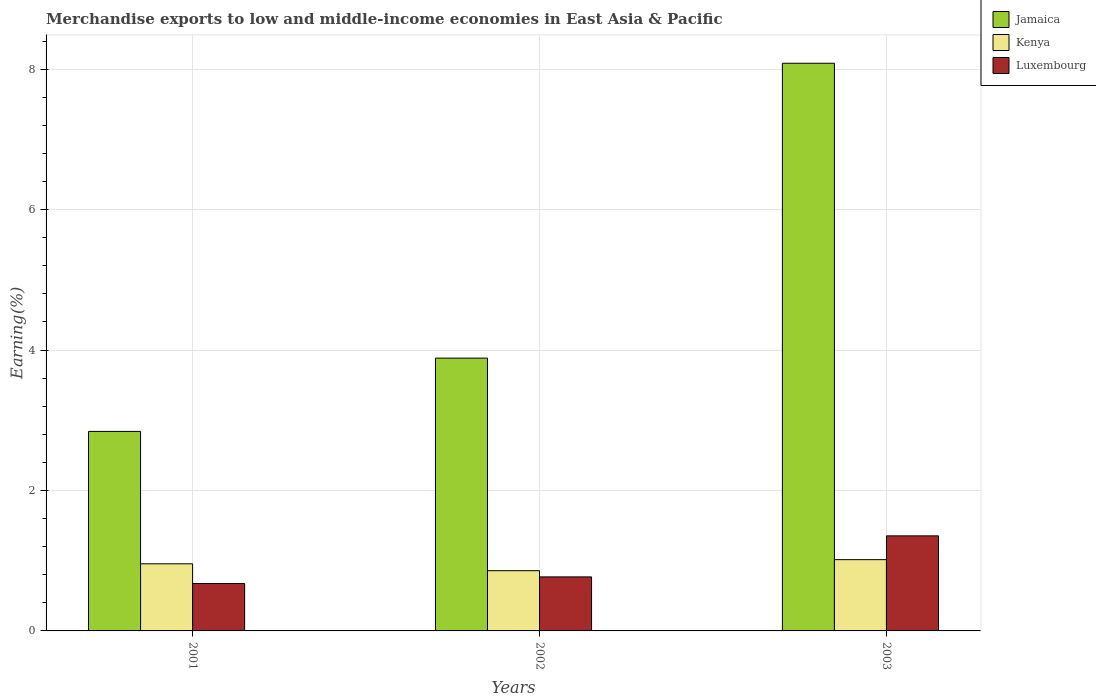How many different coloured bars are there?
Offer a very short reply. 3. Are the number of bars on each tick of the X-axis equal?
Keep it short and to the point. Yes. How many bars are there on the 2nd tick from the left?
Keep it short and to the point. 3. How many bars are there on the 2nd tick from the right?
Make the answer very short. 3. What is the label of the 3rd group of bars from the left?
Ensure brevity in your answer.  2003. In how many cases, is the number of bars for a given year not equal to the number of legend labels?
Your response must be concise. 0. What is the percentage of amount earned from merchandise exports in Kenya in 2003?
Your answer should be very brief. 1.02. Across all years, what is the maximum percentage of amount earned from merchandise exports in Luxembourg?
Your response must be concise. 1.35. Across all years, what is the minimum percentage of amount earned from merchandise exports in Jamaica?
Give a very brief answer. 2.84. In which year was the percentage of amount earned from merchandise exports in Kenya minimum?
Offer a very short reply. 2002. What is the total percentage of amount earned from merchandise exports in Kenya in the graph?
Provide a short and direct response. 2.83. What is the difference between the percentage of amount earned from merchandise exports in Luxembourg in 2002 and that in 2003?
Your answer should be very brief. -0.58. What is the difference between the percentage of amount earned from merchandise exports in Jamaica in 2003 and the percentage of amount earned from merchandise exports in Luxembourg in 2002?
Give a very brief answer. 7.32. What is the average percentage of amount earned from merchandise exports in Luxembourg per year?
Your answer should be very brief. 0.93. In the year 2001, what is the difference between the percentage of amount earned from merchandise exports in Kenya and percentage of amount earned from merchandise exports in Jamaica?
Your answer should be compact. -1.89. What is the ratio of the percentage of amount earned from merchandise exports in Luxembourg in 2001 to that in 2003?
Keep it short and to the point. 0.5. Is the percentage of amount earned from merchandise exports in Kenya in 2001 less than that in 2003?
Ensure brevity in your answer.  Yes. What is the difference between the highest and the second highest percentage of amount earned from merchandise exports in Luxembourg?
Provide a short and direct response. 0.58. What is the difference between the highest and the lowest percentage of amount earned from merchandise exports in Luxembourg?
Keep it short and to the point. 0.68. In how many years, is the percentage of amount earned from merchandise exports in Jamaica greater than the average percentage of amount earned from merchandise exports in Jamaica taken over all years?
Provide a short and direct response. 1. Is the sum of the percentage of amount earned from merchandise exports in Kenya in 2002 and 2003 greater than the maximum percentage of amount earned from merchandise exports in Jamaica across all years?
Provide a short and direct response. No. What does the 3rd bar from the left in 2002 represents?
Provide a succinct answer. Luxembourg. What does the 3rd bar from the right in 2002 represents?
Give a very brief answer. Jamaica. Is it the case that in every year, the sum of the percentage of amount earned from merchandise exports in Kenya and percentage of amount earned from merchandise exports in Luxembourg is greater than the percentage of amount earned from merchandise exports in Jamaica?
Give a very brief answer. No. How many years are there in the graph?
Provide a short and direct response. 3. What is the difference between two consecutive major ticks on the Y-axis?
Keep it short and to the point. 2. How many legend labels are there?
Give a very brief answer. 3. How are the legend labels stacked?
Offer a terse response. Vertical. What is the title of the graph?
Keep it short and to the point. Merchandise exports to low and middle-income economies in East Asia & Pacific. What is the label or title of the Y-axis?
Make the answer very short. Earning(%). What is the Earning(%) of Jamaica in 2001?
Offer a very short reply. 2.84. What is the Earning(%) of Kenya in 2001?
Offer a terse response. 0.96. What is the Earning(%) in Luxembourg in 2001?
Ensure brevity in your answer.  0.68. What is the Earning(%) in Jamaica in 2002?
Give a very brief answer. 3.89. What is the Earning(%) in Kenya in 2002?
Give a very brief answer. 0.86. What is the Earning(%) in Luxembourg in 2002?
Make the answer very short. 0.77. What is the Earning(%) in Jamaica in 2003?
Give a very brief answer. 8.08. What is the Earning(%) of Kenya in 2003?
Your answer should be compact. 1.02. What is the Earning(%) in Luxembourg in 2003?
Provide a succinct answer. 1.35. Across all years, what is the maximum Earning(%) in Jamaica?
Provide a succinct answer. 8.08. Across all years, what is the maximum Earning(%) of Kenya?
Make the answer very short. 1.02. Across all years, what is the maximum Earning(%) in Luxembourg?
Give a very brief answer. 1.35. Across all years, what is the minimum Earning(%) of Jamaica?
Provide a succinct answer. 2.84. Across all years, what is the minimum Earning(%) of Kenya?
Keep it short and to the point. 0.86. Across all years, what is the minimum Earning(%) in Luxembourg?
Offer a terse response. 0.68. What is the total Earning(%) in Jamaica in the graph?
Ensure brevity in your answer.  14.81. What is the total Earning(%) in Kenya in the graph?
Make the answer very short. 2.83. What is the total Earning(%) of Luxembourg in the graph?
Give a very brief answer. 2.8. What is the difference between the Earning(%) of Jamaica in 2001 and that in 2002?
Your answer should be compact. -1.04. What is the difference between the Earning(%) of Kenya in 2001 and that in 2002?
Your answer should be very brief. 0.1. What is the difference between the Earning(%) of Luxembourg in 2001 and that in 2002?
Give a very brief answer. -0.09. What is the difference between the Earning(%) of Jamaica in 2001 and that in 2003?
Your answer should be very brief. -5.24. What is the difference between the Earning(%) of Kenya in 2001 and that in 2003?
Your response must be concise. -0.06. What is the difference between the Earning(%) of Luxembourg in 2001 and that in 2003?
Keep it short and to the point. -0.68. What is the difference between the Earning(%) in Jamaica in 2002 and that in 2003?
Ensure brevity in your answer.  -4.2. What is the difference between the Earning(%) of Kenya in 2002 and that in 2003?
Offer a very short reply. -0.16. What is the difference between the Earning(%) in Luxembourg in 2002 and that in 2003?
Offer a very short reply. -0.58. What is the difference between the Earning(%) in Jamaica in 2001 and the Earning(%) in Kenya in 2002?
Your response must be concise. 1.98. What is the difference between the Earning(%) in Jamaica in 2001 and the Earning(%) in Luxembourg in 2002?
Your answer should be compact. 2.07. What is the difference between the Earning(%) of Kenya in 2001 and the Earning(%) of Luxembourg in 2002?
Make the answer very short. 0.19. What is the difference between the Earning(%) in Jamaica in 2001 and the Earning(%) in Kenya in 2003?
Keep it short and to the point. 1.83. What is the difference between the Earning(%) in Jamaica in 2001 and the Earning(%) in Luxembourg in 2003?
Ensure brevity in your answer.  1.49. What is the difference between the Earning(%) of Kenya in 2001 and the Earning(%) of Luxembourg in 2003?
Your answer should be compact. -0.4. What is the difference between the Earning(%) in Jamaica in 2002 and the Earning(%) in Kenya in 2003?
Give a very brief answer. 2.87. What is the difference between the Earning(%) of Jamaica in 2002 and the Earning(%) of Luxembourg in 2003?
Your answer should be very brief. 2.53. What is the difference between the Earning(%) of Kenya in 2002 and the Earning(%) of Luxembourg in 2003?
Your answer should be very brief. -0.5. What is the average Earning(%) of Jamaica per year?
Your response must be concise. 4.94. What is the average Earning(%) in Kenya per year?
Your answer should be compact. 0.94. What is the average Earning(%) of Luxembourg per year?
Your response must be concise. 0.93. In the year 2001, what is the difference between the Earning(%) in Jamaica and Earning(%) in Kenya?
Offer a very short reply. 1.89. In the year 2001, what is the difference between the Earning(%) in Jamaica and Earning(%) in Luxembourg?
Offer a terse response. 2.17. In the year 2001, what is the difference between the Earning(%) in Kenya and Earning(%) in Luxembourg?
Offer a very short reply. 0.28. In the year 2002, what is the difference between the Earning(%) of Jamaica and Earning(%) of Kenya?
Make the answer very short. 3.03. In the year 2002, what is the difference between the Earning(%) of Jamaica and Earning(%) of Luxembourg?
Your response must be concise. 3.12. In the year 2002, what is the difference between the Earning(%) of Kenya and Earning(%) of Luxembourg?
Provide a short and direct response. 0.09. In the year 2003, what is the difference between the Earning(%) of Jamaica and Earning(%) of Kenya?
Your answer should be very brief. 7.07. In the year 2003, what is the difference between the Earning(%) in Jamaica and Earning(%) in Luxembourg?
Provide a succinct answer. 6.73. In the year 2003, what is the difference between the Earning(%) in Kenya and Earning(%) in Luxembourg?
Provide a succinct answer. -0.34. What is the ratio of the Earning(%) of Jamaica in 2001 to that in 2002?
Ensure brevity in your answer.  0.73. What is the ratio of the Earning(%) of Kenya in 2001 to that in 2002?
Keep it short and to the point. 1.11. What is the ratio of the Earning(%) of Luxembourg in 2001 to that in 2002?
Offer a very short reply. 0.88. What is the ratio of the Earning(%) of Jamaica in 2001 to that in 2003?
Provide a succinct answer. 0.35. What is the ratio of the Earning(%) in Kenya in 2001 to that in 2003?
Your response must be concise. 0.94. What is the ratio of the Earning(%) in Luxembourg in 2001 to that in 2003?
Your answer should be very brief. 0.5. What is the ratio of the Earning(%) in Jamaica in 2002 to that in 2003?
Ensure brevity in your answer.  0.48. What is the ratio of the Earning(%) in Kenya in 2002 to that in 2003?
Your answer should be compact. 0.84. What is the ratio of the Earning(%) of Luxembourg in 2002 to that in 2003?
Make the answer very short. 0.57. What is the difference between the highest and the second highest Earning(%) in Jamaica?
Give a very brief answer. 4.2. What is the difference between the highest and the second highest Earning(%) of Kenya?
Your response must be concise. 0.06. What is the difference between the highest and the second highest Earning(%) in Luxembourg?
Offer a terse response. 0.58. What is the difference between the highest and the lowest Earning(%) in Jamaica?
Your response must be concise. 5.24. What is the difference between the highest and the lowest Earning(%) of Kenya?
Your answer should be very brief. 0.16. What is the difference between the highest and the lowest Earning(%) in Luxembourg?
Ensure brevity in your answer.  0.68. 